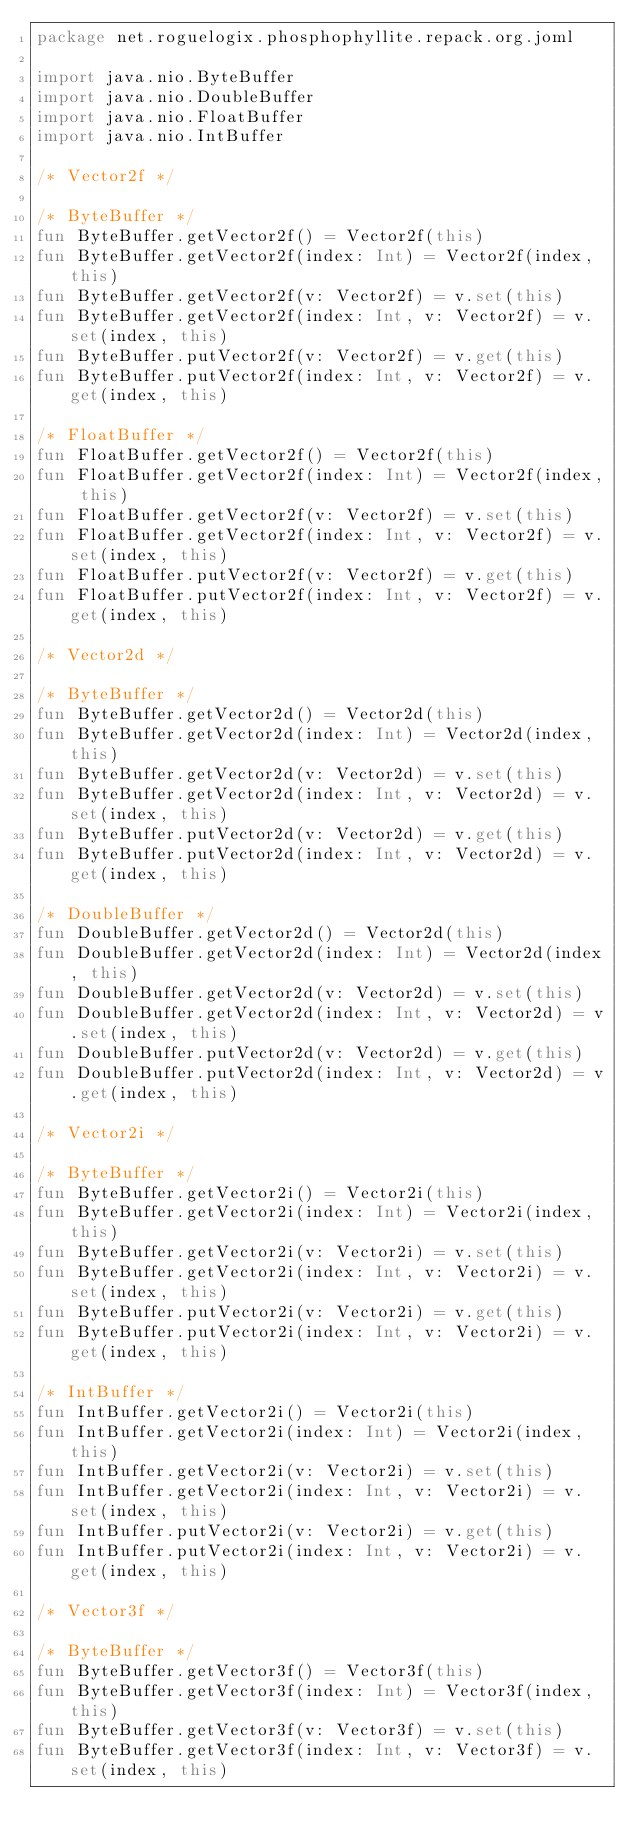<code> <loc_0><loc_0><loc_500><loc_500><_Kotlin_>package net.roguelogix.phosphophyllite.repack.org.joml

import java.nio.ByteBuffer
import java.nio.DoubleBuffer
import java.nio.FloatBuffer
import java.nio.IntBuffer

/* Vector2f */

/* ByteBuffer */
fun ByteBuffer.getVector2f() = Vector2f(this)
fun ByteBuffer.getVector2f(index: Int) = Vector2f(index, this)
fun ByteBuffer.getVector2f(v: Vector2f) = v.set(this)
fun ByteBuffer.getVector2f(index: Int, v: Vector2f) = v.set(index, this)
fun ByteBuffer.putVector2f(v: Vector2f) = v.get(this)
fun ByteBuffer.putVector2f(index: Int, v: Vector2f) = v.get(index, this)

/* FloatBuffer */
fun FloatBuffer.getVector2f() = Vector2f(this)
fun FloatBuffer.getVector2f(index: Int) = Vector2f(index, this)
fun FloatBuffer.getVector2f(v: Vector2f) = v.set(this)
fun FloatBuffer.getVector2f(index: Int, v: Vector2f) = v.set(index, this)
fun FloatBuffer.putVector2f(v: Vector2f) = v.get(this)
fun FloatBuffer.putVector2f(index: Int, v: Vector2f) = v.get(index, this)

/* Vector2d */

/* ByteBuffer */
fun ByteBuffer.getVector2d() = Vector2d(this)
fun ByteBuffer.getVector2d(index: Int) = Vector2d(index, this)
fun ByteBuffer.getVector2d(v: Vector2d) = v.set(this)
fun ByteBuffer.getVector2d(index: Int, v: Vector2d) = v.set(index, this)
fun ByteBuffer.putVector2d(v: Vector2d) = v.get(this)
fun ByteBuffer.putVector2d(index: Int, v: Vector2d) = v.get(index, this)

/* DoubleBuffer */
fun DoubleBuffer.getVector2d() = Vector2d(this)
fun DoubleBuffer.getVector2d(index: Int) = Vector2d(index, this)
fun DoubleBuffer.getVector2d(v: Vector2d) = v.set(this)
fun DoubleBuffer.getVector2d(index: Int, v: Vector2d) = v.set(index, this)
fun DoubleBuffer.putVector2d(v: Vector2d) = v.get(this)
fun DoubleBuffer.putVector2d(index: Int, v: Vector2d) = v.get(index, this)

/* Vector2i */

/* ByteBuffer */
fun ByteBuffer.getVector2i() = Vector2i(this)
fun ByteBuffer.getVector2i(index: Int) = Vector2i(index, this)
fun ByteBuffer.getVector2i(v: Vector2i) = v.set(this)
fun ByteBuffer.getVector2i(index: Int, v: Vector2i) = v.set(index, this)
fun ByteBuffer.putVector2i(v: Vector2i) = v.get(this)
fun ByteBuffer.putVector2i(index: Int, v: Vector2i) = v.get(index, this)

/* IntBuffer */
fun IntBuffer.getVector2i() = Vector2i(this)
fun IntBuffer.getVector2i(index: Int) = Vector2i(index, this)
fun IntBuffer.getVector2i(v: Vector2i) = v.set(this)
fun IntBuffer.getVector2i(index: Int, v: Vector2i) = v.set(index, this)
fun IntBuffer.putVector2i(v: Vector2i) = v.get(this)
fun IntBuffer.putVector2i(index: Int, v: Vector2i) = v.get(index, this)

/* Vector3f */

/* ByteBuffer */
fun ByteBuffer.getVector3f() = Vector3f(this)
fun ByteBuffer.getVector3f(index: Int) = Vector3f(index, this)
fun ByteBuffer.getVector3f(v: Vector3f) = v.set(this)
fun ByteBuffer.getVector3f(index: Int, v: Vector3f) = v.set(index, this)</code> 